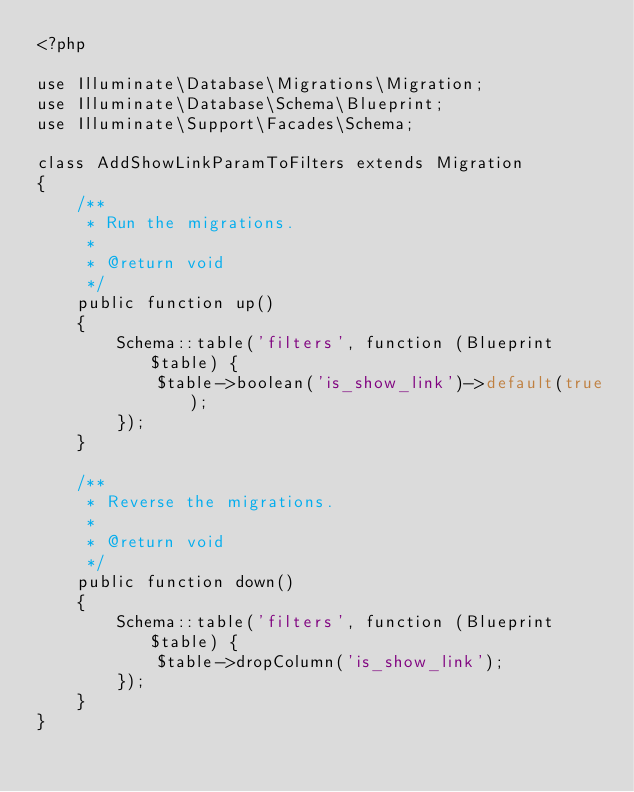<code> <loc_0><loc_0><loc_500><loc_500><_PHP_><?php

use Illuminate\Database\Migrations\Migration;
use Illuminate\Database\Schema\Blueprint;
use Illuminate\Support\Facades\Schema;

class AddShowLinkParamToFilters extends Migration
{
    /**
     * Run the migrations.
     *
     * @return void
     */
    public function up()
    {
        Schema::table('filters', function (Blueprint $table) {
            $table->boolean('is_show_link')->default(true);
        });
    }

    /**
     * Reverse the migrations.
     *
     * @return void
     */
    public function down()
    {
        Schema::table('filters', function (Blueprint $table) {
            $table->dropColumn('is_show_link');
        });
    }
}
</code> 